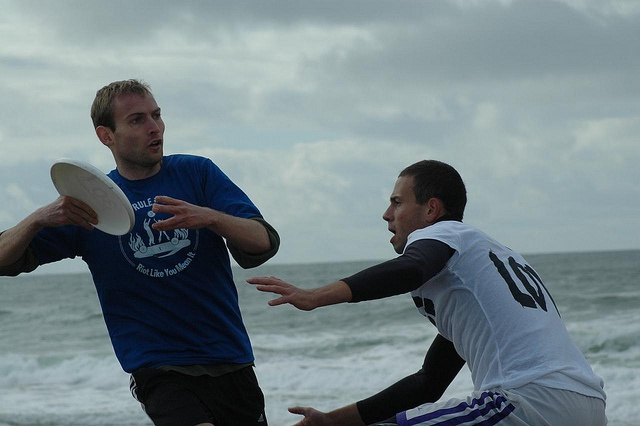Describe the objects in this image and their specific colors. I can see people in lightblue, black, gray, and navy tones, people in lightblue, black, and gray tones, and frisbee in lightblue, gray, darkgray, and black tones in this image. 